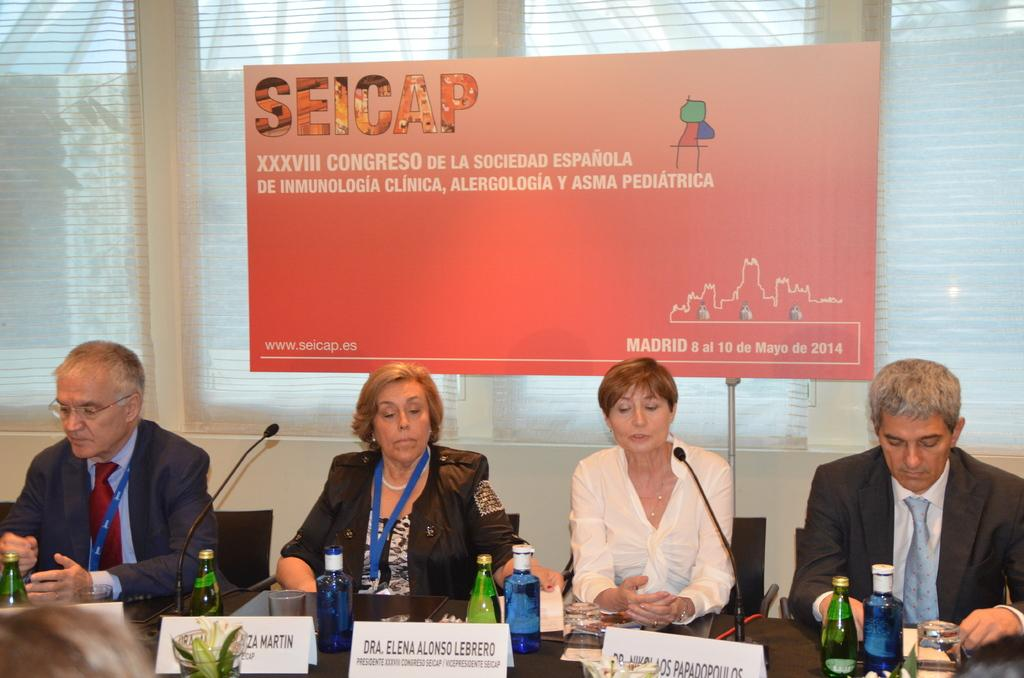Provide a one-sentence caption for the provided image. Four people hold a meeting for SEICAP in Madrid. 